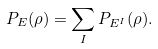Convert formula to latex. <formula><loc_0><loc_0><loc_500><loc_500>P _ { E } ( \rho ) & = \sum _ { I } P _ { E ^ { I } } ( \rho ) .</formula> 